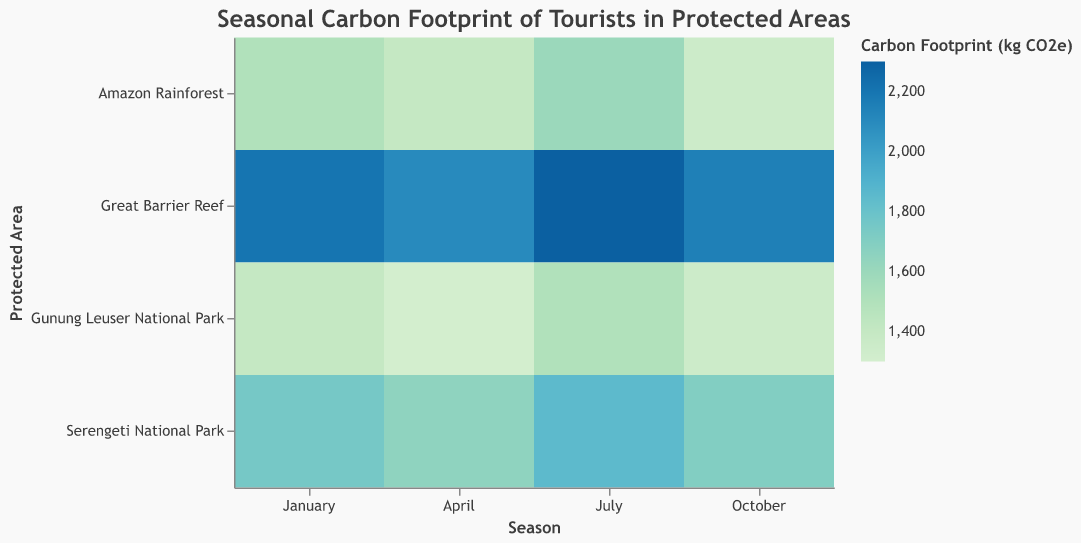What is the title of the heatmap? The title of the heatmap is usually found at the top of the figure. Reading the top section, we see it is "Seasonal Carbon Footprint of Tourists in Protected Areas."
Answer: Seasonal Carbon Footprint of Tourists in Protected Areas Which region has the highest carbon footprint in July? We can locate 'July' on the x-axis and then look for the highest color intensity (which should correspond to the highest footprint value) along that column. Upon examining, "Great Barrier Reef" has the highest footprint in July, with a value of 2300 kg CO2e.
Answer: Great Barrier Reef What is the carbon footprint of tourists visiting Gunung Leuser National Park in April? First, locate the row for Gunung Leuser National Park. Then, find the intersection of this row with the April column. The cell shows the value "1300" kg CO2e.
Answer: 1300 kg CO2e Compare the carbon footprint of tourists in the Amazon Rainforest for January and October. Which month has a higher footprint? Locate the rows for the Amazon Rainforest and look at the values for January (1500 kg CO2e) and October (1350 kg CO2e). January's value is higher.
Answer: January During which season does the Great Barrier Reef have the lowest carbon footprint? Find the row for Great Barrier Reef and compare the values across all months. The lowest value is in April with 2100 kg CO2e.
Answer: April Is the carbon footprint generally higher in July or January across all regions? Compare the overall trend by looking at the July and January columns. July has higher or similar footprints across most regions.
Answer: July What is the difference in the carbon footprint between the Amazon Rainforest and Serengeti National Park in April? Locate the values for April for both Amazon Rainforest (1400 kg CO2e) and Serengeti National Park (1650 kg CO2e). The difference is 1650 - 1400 = 250 kg CO2e.
Answer: 250 kg CO2e Which region shows the least variation in carbon footprint across the seasons? Check the rows for each region and compare how consistent the values are. Gunung Leuser National Park shows the least variation, with values ranging from 1300 to 1500 kg CO2e.
Answer: Gunung Leuser National Park How does the carbon footprint of tourists in Great Barrier Reef change from January to October? Examine the values for Great Barrier Reef in January (2200 kg CO2e) and October (2150 kg CO2e). The footprint decreases by 50 kg CO2e.
Answer: Decreases by 50 kg CO2e What activity contributes to the highest carbon footprint in the Serengeti National Park? Look at the Serengeti National Park row for the highest value of carbon footprint, which is in July (1850 kg CO2e), corresponding to Wilderness Camping.
Answer: Wilderness Camping 